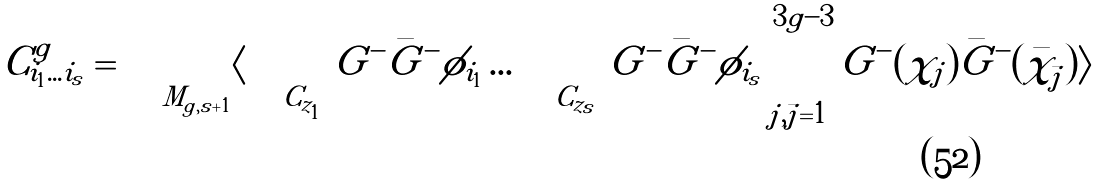Convert formula to latex. <formula><loc_0><loc_0><loc_500><loc_500>C _ { i _ { 1 } \dots i _ { s } } ^ { g } = \int _ { M _ { g , s + 1 } } \langle \oint _ { C _ { z _ { 1 } } } \, G ^ { - } { \bar { G } } ^ { - } \phi _ { i _ { 1 } } \dots \oint _ { C _ { z _ { s } } } \, G ^ { - } { \bar { G } } ^ { - } \phi _ { i _ { s } } \prod _ { j , { \bar { j } } = 1 } ^ { 3 g - 3 } G ^ { - } ( \chi _ { j } ) { \bar { G } } ^ { - } ( { \bar { \chi } } _ { \bar { j } } ) \rangle</formula> 